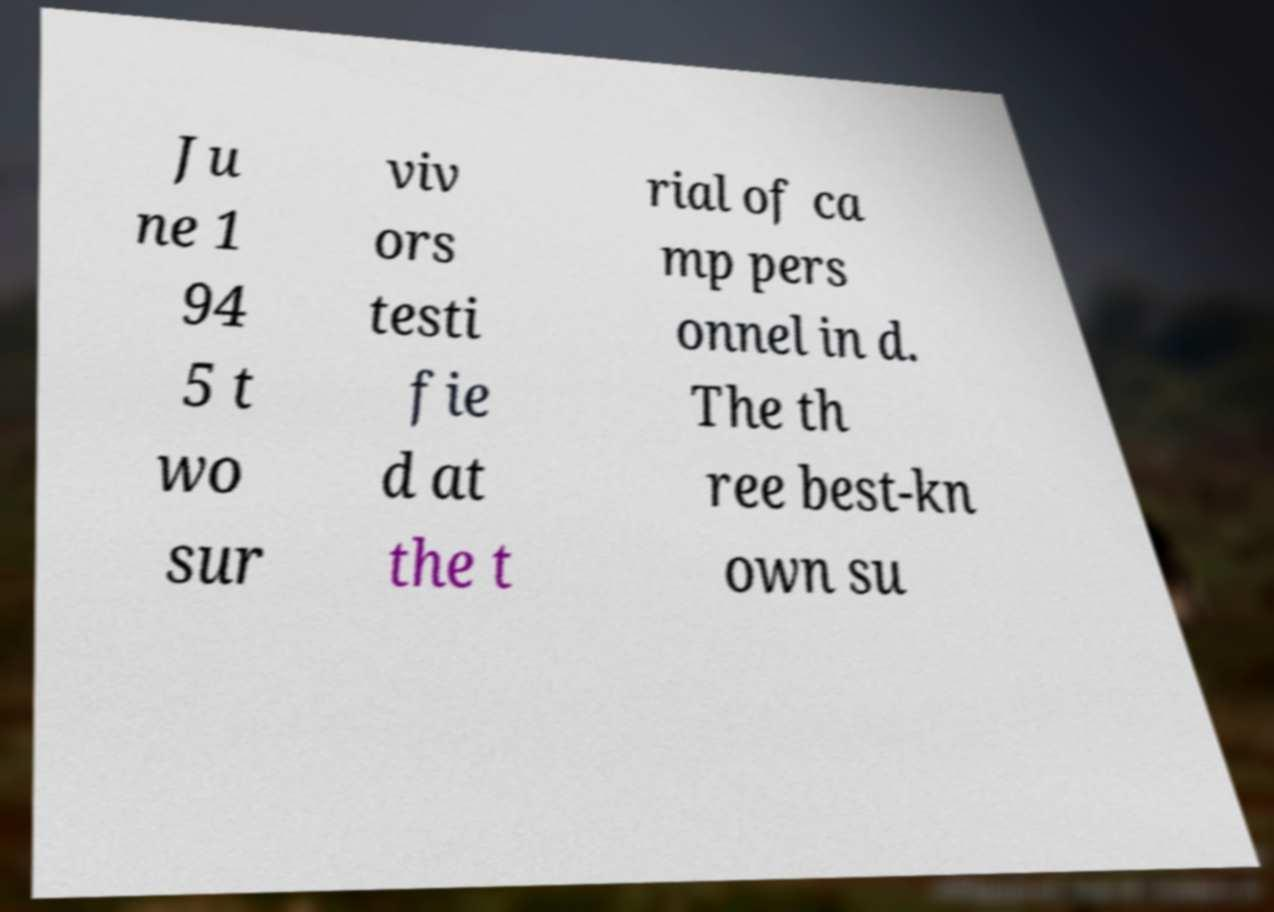Please read and relay the text visible in this image. What does it say? Ju ne 1 94 5 t wo sur viv ors testi fie d at the t rial of ca mp pers onnel in d. The th ree best-kn own su 